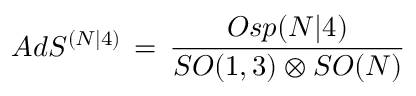<formula> <loc_0><loc_0><loc_500><loc_500>A d S ^ { ( N | 4 ) } \, = \, \frac { O s p ( N | 4 ) } { S O ( 1 , 3 ) \otimes S O ( N ) }</formula> 